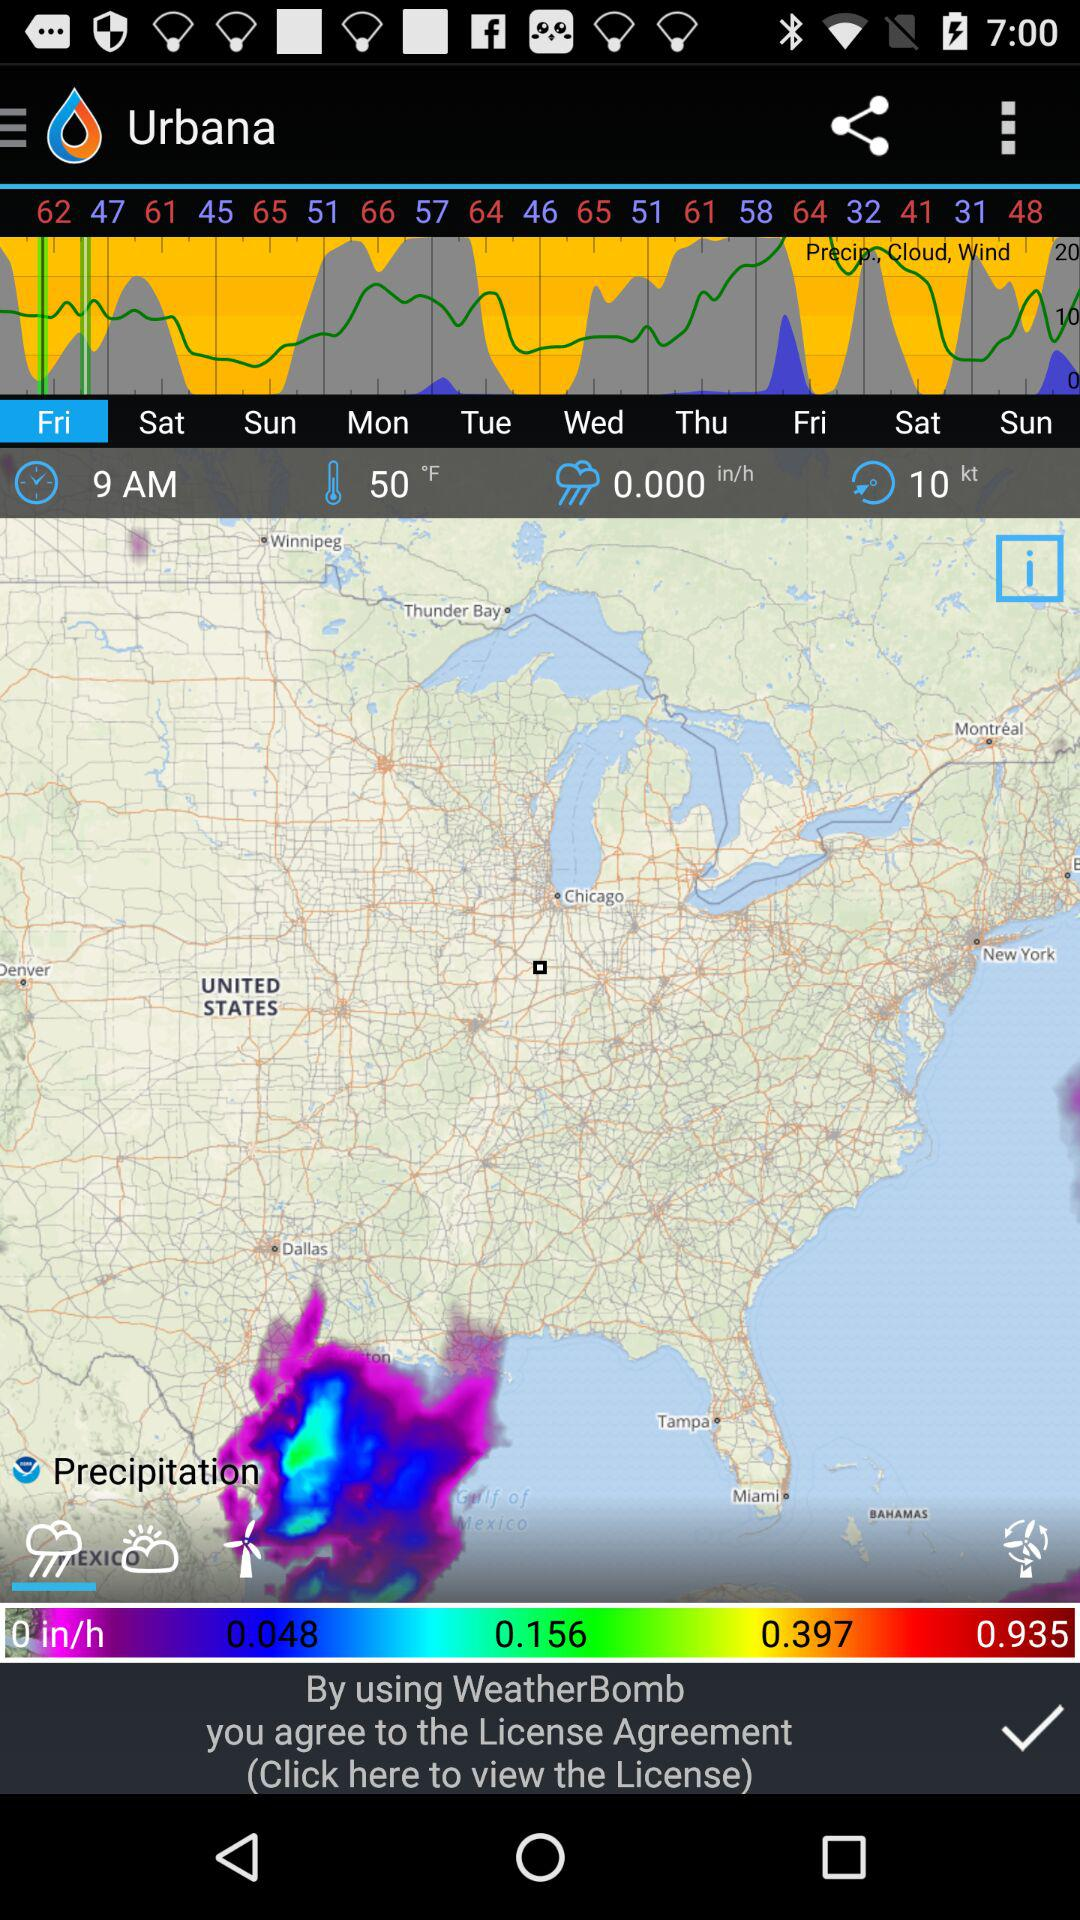What is the temperature of the place?
Answer the question using a single word or phrase. 50 °F 